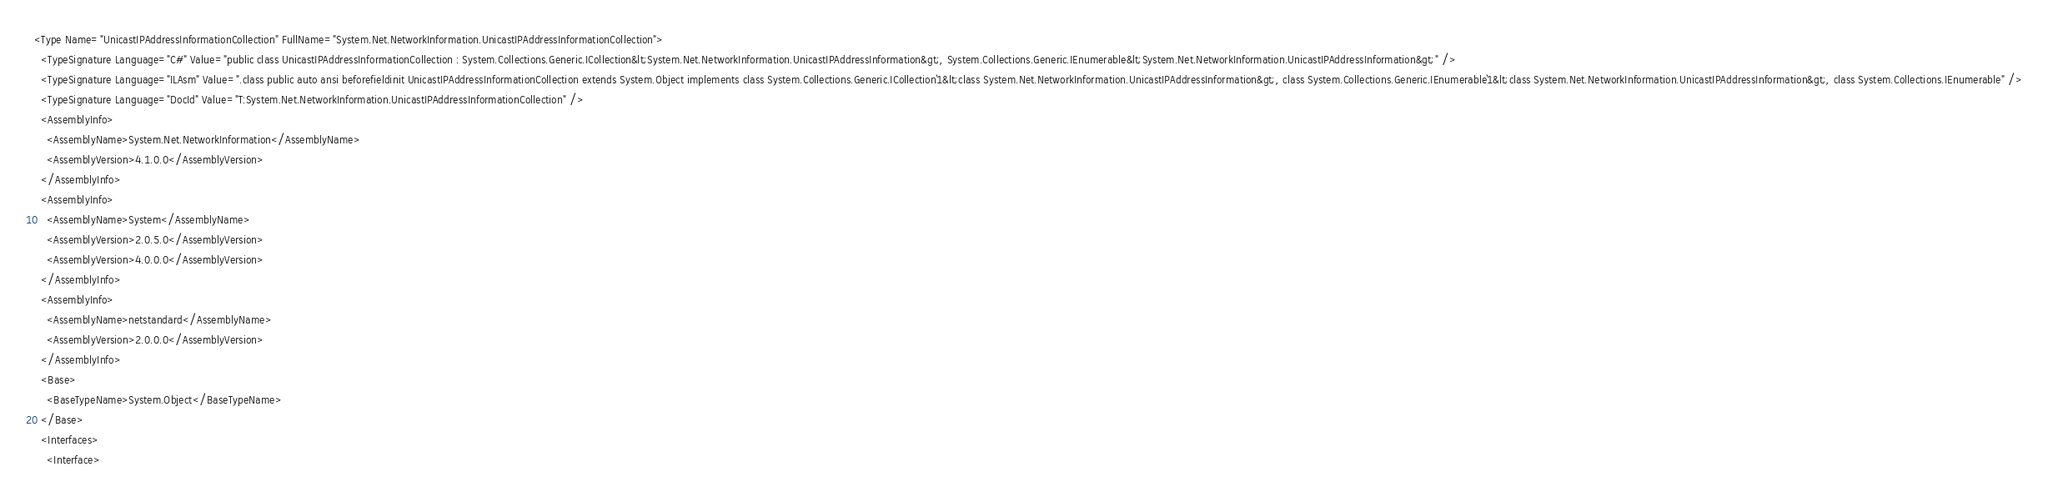<code> <loc_0><loc_0><loc_500><loc_500><_XML_><Type Name="UnicastIPAddressInformationCollection" FullName="System.Net.NetworkInformation.UnicastIPAddressInformationCollection">
  <TypeSignature Language="C#" Value="public class UnicastIPAddressInformationCollection : System.Collections.Generic.ICollection&lt;System.Net.NetworkInformation.UnicastIPAddressInformation&gt;, System.Collections.Generic.IEnumerable&lt;System.Net.NetworkInformation.UnicastIPAddressInformation&gt;" />
  <TypeSignature Language="ILAsm" Value=".class public auto ansi beforefieldinit UnicastIPAddressInformationCollection extends System.Object implements class System.Collections.Generic.ICollection`1&lt;class System.Net.NetworkInformation.UnicastIPAddressInformation&gt;, class System.Collections.Generic.IEnumerable`1&lt;class System.Net.NetworkInformation.UnicastIPAddressInformation&gt;, class System.Collections.IEnumerable" />
  <TypeSignature Language="DocId" Value="T:System.Net.NetworkInformation.UnicastIPAddressInformationCollection" />
  <AssemblyInfo>
    <AssemblyName>System.Net.NetworkInformation</AssemblyName>
    <AssemblyVersion>4.1.0.0</AssemblyVersion>
  </AssemblyInfo>
  <AssemblyInfo>
    <AssemblyName>System</AssemblyName>
    <AssemblyVersion>2.0.5.0</AssemblyVersion>
    <AssemblyVersion>4.0.0.0</AssemblyVersion>
  </AssemblyInfo>
  <AssemblyInfo>
    <AssemblyName>netstandard</AssemblyName>
    <AssemblyVersion>2.0.0.0</AssemblyVersion>
  </AssemblyInfo>
  <Base>
    <BaseTypeName>System.Object</BaseTypeName>
  </Base>
  <Interfaces>
    <Interface></code> 